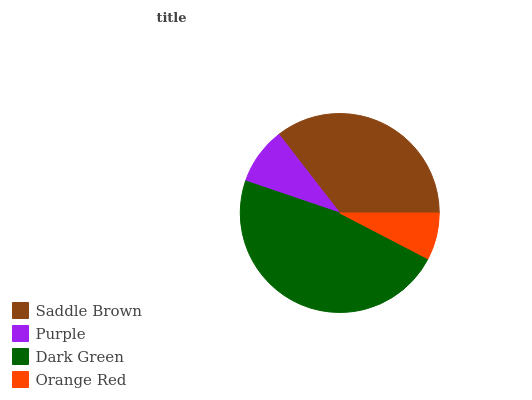Is Orange Red the minimum?
Answer yes or no. Yes. Is Dark Green the maximum?
Answer yes or no. Yes. Is Purple the minimum?
Answer yes or no. No. Is Purple the maximum?
Answer yes or no. No. Is Saddle Brown greater than Purple?
Answer yes or no. Yes. Is Purple less than Saddle Brown?
Answer yes or no. Yes. Is Purple greater than Saddle Brown?
Answer yes or no. No. Is Saddle Brown less than Purple?
Answer yes or no. No. Is Saddle Brown the high median?
Answer yes or no. Yes. Is Purple the low median?
Answer yes or no. Yes. Is Orange Red the high median?
Answer yes or no. No. Is Saddle Brown the low median?
Answer yes or no. No. 